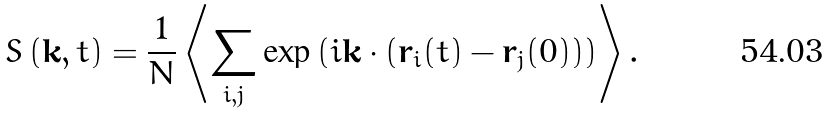<formula> <loc_0><loc_0><loc_500><loc_500>S \left ( { \mathbf k } , t \right ) = \frac { 1 } { N } \left \langle \sum _ { i , j } \exp \left ( i { \mathbf k } \cdot \left ( { \mathbf r } _ { i } ( t ) - { \mathbf r } _ { j } ( 0 ) \right ) \right ) \right \rangle .</formula> 